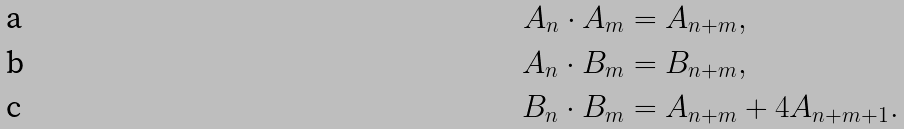<formula> <loc_0><loc_0><loc_500><loc_500>{ } A _ { n } \cdot A _ { m } & = A _ { n + m } , \\ A _ { n } \cdot B _ { m } & = B _ { n + m } , \\ B _ { n } \cdot B _ { m } & = A _ { n + m } + 4 A _ { n + m + 1 } .</formula> 